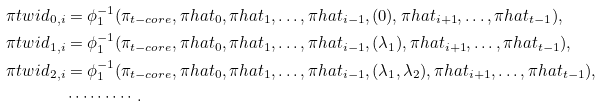Convert formula to latex. <formula><loc_0><loc_0><loc_500><loc_500>\pi t w i d _ { 0 , i } & = \phi _ { 1 } ^ { - 1 } ( \pi _ { t - c o r e } , \pi h a t _ { 0 } , \pi h a t _ { 1 } , \dots , \pi h a t _ { i - 1 } , ( 0 ) , \pi h a t _ { i + 1 } , \dots , \pi h a t _ { t - 1 } ) , \\ \pi t w i d _ { 1 , i } & = \phi _ { 1 } ^ { - 1 } ( \pi _ { t - c o r e } , \pi h a t _ { 0 } , \pi h a t _ { 1 } , \dots , \pi h a t _ { i - 1 } , ( \lambda _ { 1 } ) , \pi h a t _ { i + 1 } , \dots , \pi h a t _ { t - 1 } ) , \\ \pi t w i d _ { 2 , i } & = \phi _ { 1 } ^ { - 1 } ( \pi _ { t - c o r e } , \pi h a t _ { 0 } , \pi h a t _ { 1 } , \dots , \pi h a t _ { i - 1 } , ( \lambda _ { 1 } , \lambda _ { 2 } ) , \pi h a t _ { i + 1 } , \dots , \pi h a t _ { t - 1 } ) , \\ & \cdots \cdots \cdots .</formula> 